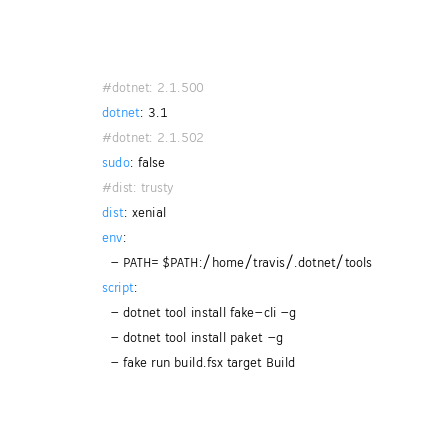<code> <loc_0><loc_0><loc_500><loc_500><_YAML_>#dotnet: 2.1.500
dotnet: 3.1
#dotnet: 2.1.502
sudo: false
#dist: trusty
dist: xenial
env:
  - PATH=$PATH:/home/travis/.dotnet/tools
script:
  - dotnet tool install fake-cli -g
  - dotnet tool install paket -g
  - fake run build.fsx target Build
</code> 